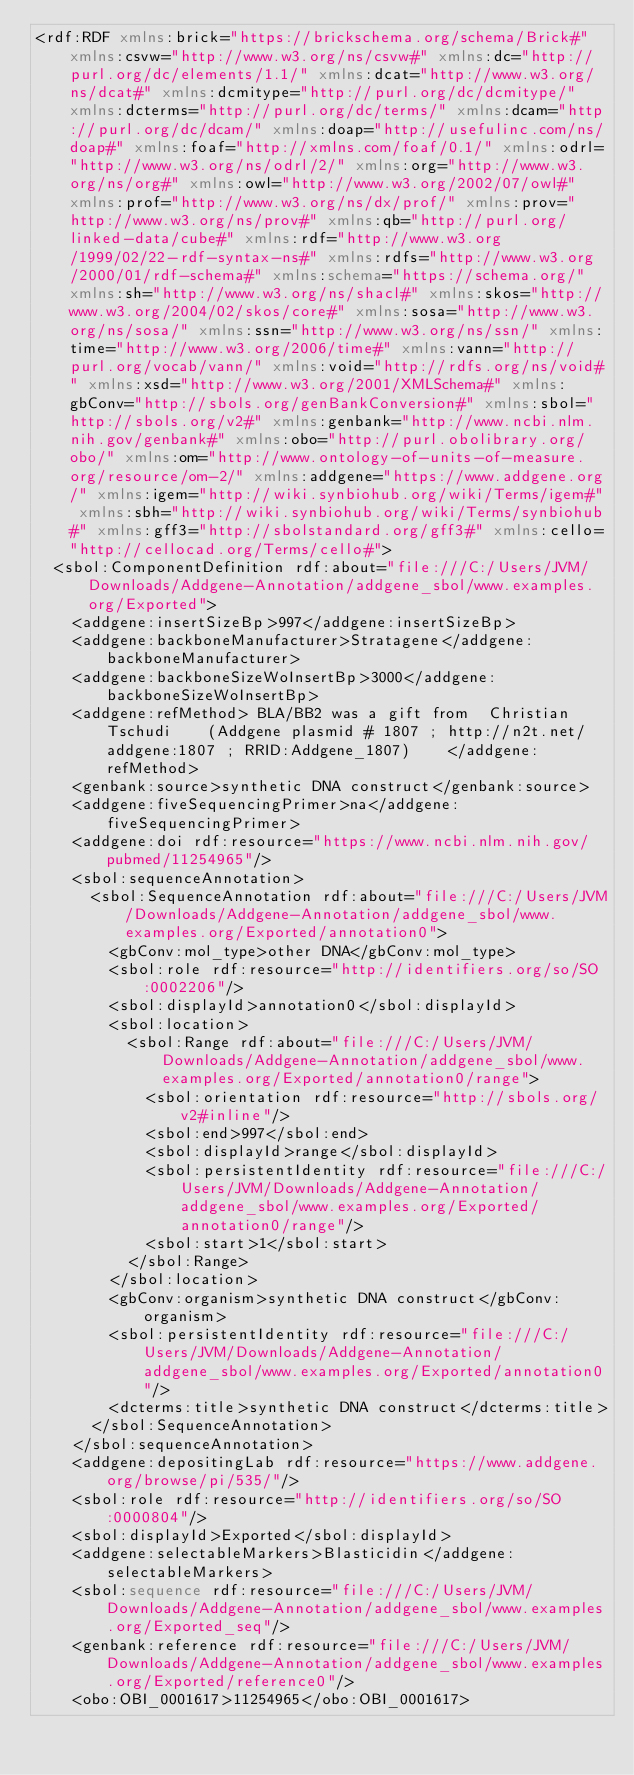Convert code to text. <code><loc_0><loc_0><loc_500><loc_500><_XML_><rdf:RDF xmlns:brick="https://brickschema.org/schema/Brick#" xmlns:csvw="http://www.w3.org/ns/csvw#" xmlns:dc="http://purl.org/dc/elements/1.1/" xmlns:dcat="http://www.w3.org/ns/dcat#" xmlns:dcmitype="http://purl.org/dc/dcmitype/" xmlns:dcterms="http://purl.org/dc/terms/" xmlns:dcam="http://purl.org/dc/dcam/" xmlns:doap="http://usefulinc.com/ns/doap#" xmlns:foaf="http://xmlns.com/foaf/0.1/" xmlns:odrl="http://www.w3.org/ns/odrl/2/" xmlns:org="http://www.w3.org/ns/org#" xmlns:owl="http://www.w3.org/2002/07/owl#" xmlns:prof="http://www.w3.org/ns/dx/prof/" xmlns:prov="http://www.w3.org/ns/prov#" xmlns:qb="http://purl.org/linked-data/cube#" xmlns:rdf="http://www.w3.org/1999/02/22-rdf-syntax-ns#" xmlns:rdfs="http://www.w3.org/2000/01/rdf-schema#" xmlns:schema="https://schema.org/" xmlns:sh="http://www.w3.org/ns/shacl#" xmlns:skos="http://www.w3.org/2004/02/skos/core#" xmlns:sosa="http://www.w3.org/ns/sosa/" xmlns:ssn="http://www.w3.org/ns/ssn/" xmlns:time="http://www.w3.org/2006/time#" xmlns:vann="http://purl.org/vocab/vann/" xmlns:void="http://rdfs.org/ns/void#" xmlns:xsd="http://www.w3.org/2001/XMLSchema#" xmlns:gbConv="http://sbols.org/genBankConversion#" xmlns:sbol="http://sbols.org/v2#" xmlns:genbank="http://www.ncbi.nlm.nih.gov/genbank#" xmlns:obo="http://purl.obolibrary.org/obo/" xmlns:om="http://www.ontology-of-units-of-measure.org/resource/om-2/" xmlns:addgene="https://www.addgene.org/" xmlns:igem="http://wiki.synbiohub.org/wiki/Terms/igem#" xmlns:sbh="http://wiki.synbiohub.org/wiki/Terms/synbiohub#" xmlns:gff3="http://sbolstandard.org/gff3#" xmlns:cello="http://cellocad.org/Terms/cello#">
  <sbol:ComponentDefinition rdf:about="file:///C:/Users/JVM/Downloads/Addgene-Annotation/addgene_sbol/www.examples.org/Exported">
    <addgene:insertSizeBp>997</addgene:insertSizeBp>
    <addgene:backboneManufacturer>Stratagene</addgene:backboneManufacturer>
    <addgene:backboneSizeWoInsertBp>3000</addgene:backboneSizeWoInsertBp>
    <addgene:refMethod> BLA/BB2 was a gift from  Christian Tschudi    (Addgene plasmid # 1807 ; http://n2t.net/addgene:1807 ; RRID:Addgene_1807)    </addgene:refMethod>
    <genbank:source>synthetic DNA construct</genbank:source>
    <addgene:fiveSequencingPrimer>na</addgene:fiveSequencingPrimer>
    <addgene:doi rdf:resource="https://www.ncbi.nlm.nih.gov/pubmed/11254965"/>
    <sbol:sequenceAnnotation>
      <sbol:SequenceAnnotation rdf:about="file:///C:/Users/JVM/Downloads/Addgene-Annotation/addgene_sbol/www.examples.org/Exported/annotation0">
        <gbConv:mol_type>other DNA</gbConv:mol_type>
        <sbol:role rdf:resource="http://identifiers.org/so/SO:0002206"/>
        <sbol:displayId>annotation0</sbol:displayId>
        <sbol:location>
          <sbol:Range rdf:about="file:///C:/Users/JVM/Downloads/Addgene-Annotation/addgene_sbol/www.examples.org/Exported/annotation0/range">
            <sbol:orientation rdf:resource="http://sbols.org/v2#inline"/>
            <sbol:end>997</sbol:end>
            <sbol:displayId>range</sbol:displayId>
            <sbol:persistentIdentity rdf:resource="file:///C:/Users/JVM/Downloads/Addgene-Annotation/addgene_sbol/www.examples.org/Exported/annotation0/range"/>
            <sbol:start>1</sbol:start>
          </sbol:Range>
        </sbol:location>
        <gbConv:organism>synthetic DNA construct</gbConv:organism>
        <sbol:persistentIdentity rdf:resource="file:///C:/Users/JVM/Downloads/Addgene-Annotation/addgene_sbol/www.examples.org/Exported/annotation0"/>
        <dcterms:title>synthetic DNA construct</dcterms:title>
      </sbol:SequenceAnnotation>
    </sbol:sequenceAnnotation>
    <addgene:depositingLab rdf:resource="https://www.addgene.org/browse/pi/535/"/>
    <sbol:role rdf:resource="http://identifiers.org/so/SO:0000804"/>
    <sbol:displayId>Exported</sbol:displayId>
    <addgene:selectableMarkers>Blasticidin</addgene:selectableMarkers>
    <sbol:sequence rdf:resource="file:///C:/Users/JVM/Downloads/Addgene-Annotation/addgene_sbol/www.examples.org/Exported_seq"/>
    <genbank:reference rdf:resource="file:///C:/Users/JVM/Downloads/Addgene-Annotation/addgene_sbol/www.examples.org/Exported/reference0"/>
    <obo:OBI_0001617>11254965</obo:OBI_0001617></code> 